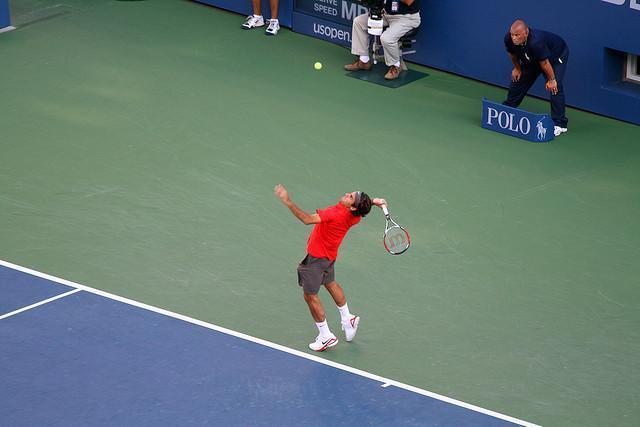How many people are there?
Give a very brief answer. 3. 